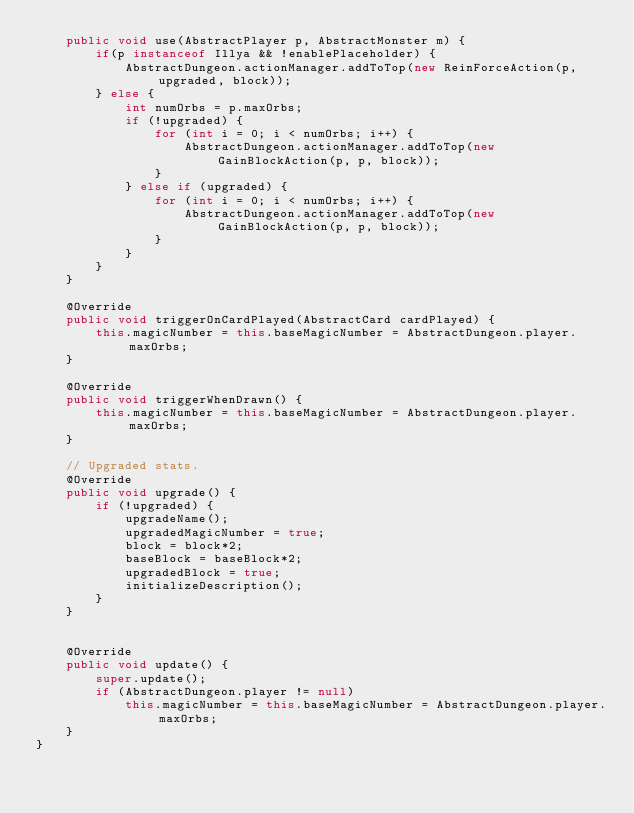Convert code to text. <code><loc_0><loc_0><loc_500><loc_500><_Java_>    public void use(AbstractPlayer p, AbstractMonster m) {
        if(p instanceof Illya && !enablePlaceholder) {
            AbstractDungeon.actionManager.addToTop(new ReinForceAction(p, upgraded, block));
        } else {
            int numOrbs = p.maxOrbs;
            if (!upgraded) {
                for (int i = 0; i < numOrbs; i++) {
                    AbstractDungeon.actionManager.addToTop(new GainBlockAction(p, p, block));
                }
            } else if (upgraded) {
                for (int i = 0; i < numOrbs; i++) {
                    AbstractDungeon.actionManager.addToTop(new GainBlockAction(p, p, block));
                }
            }
        }
    }

    @Override
    public void triggerOnCardPlayed(AbstractCard cardPlayed) {
        this.magicNumber = this.baseMagicNumber = AbstractDungeon.player.maxOrbs;
    }

    @Override
    public void triggerWhenDrawn() {
        this.magicNumber = this.baseMagicNumber = AbstractDungeon.player.maxOrbs;
    }

    // Upgraded stats.
    @Override
    public void upgrade() {
        if (!upgraded) {
            upgradeName();
            upgradedMagicNumber = true;
            block = block*2;
            baseBlock = baseBlock*2;
            upgradedBlock = true;
            initializeDescription();
        }
    }


    @Override
    public void update() {
        super.update();
        if (AbstractDungeon.player != null)
            this.magicNumber = this.baseMagicNumber = AbstractDungeon.player.maxOrbs;
    }
}
</code> 